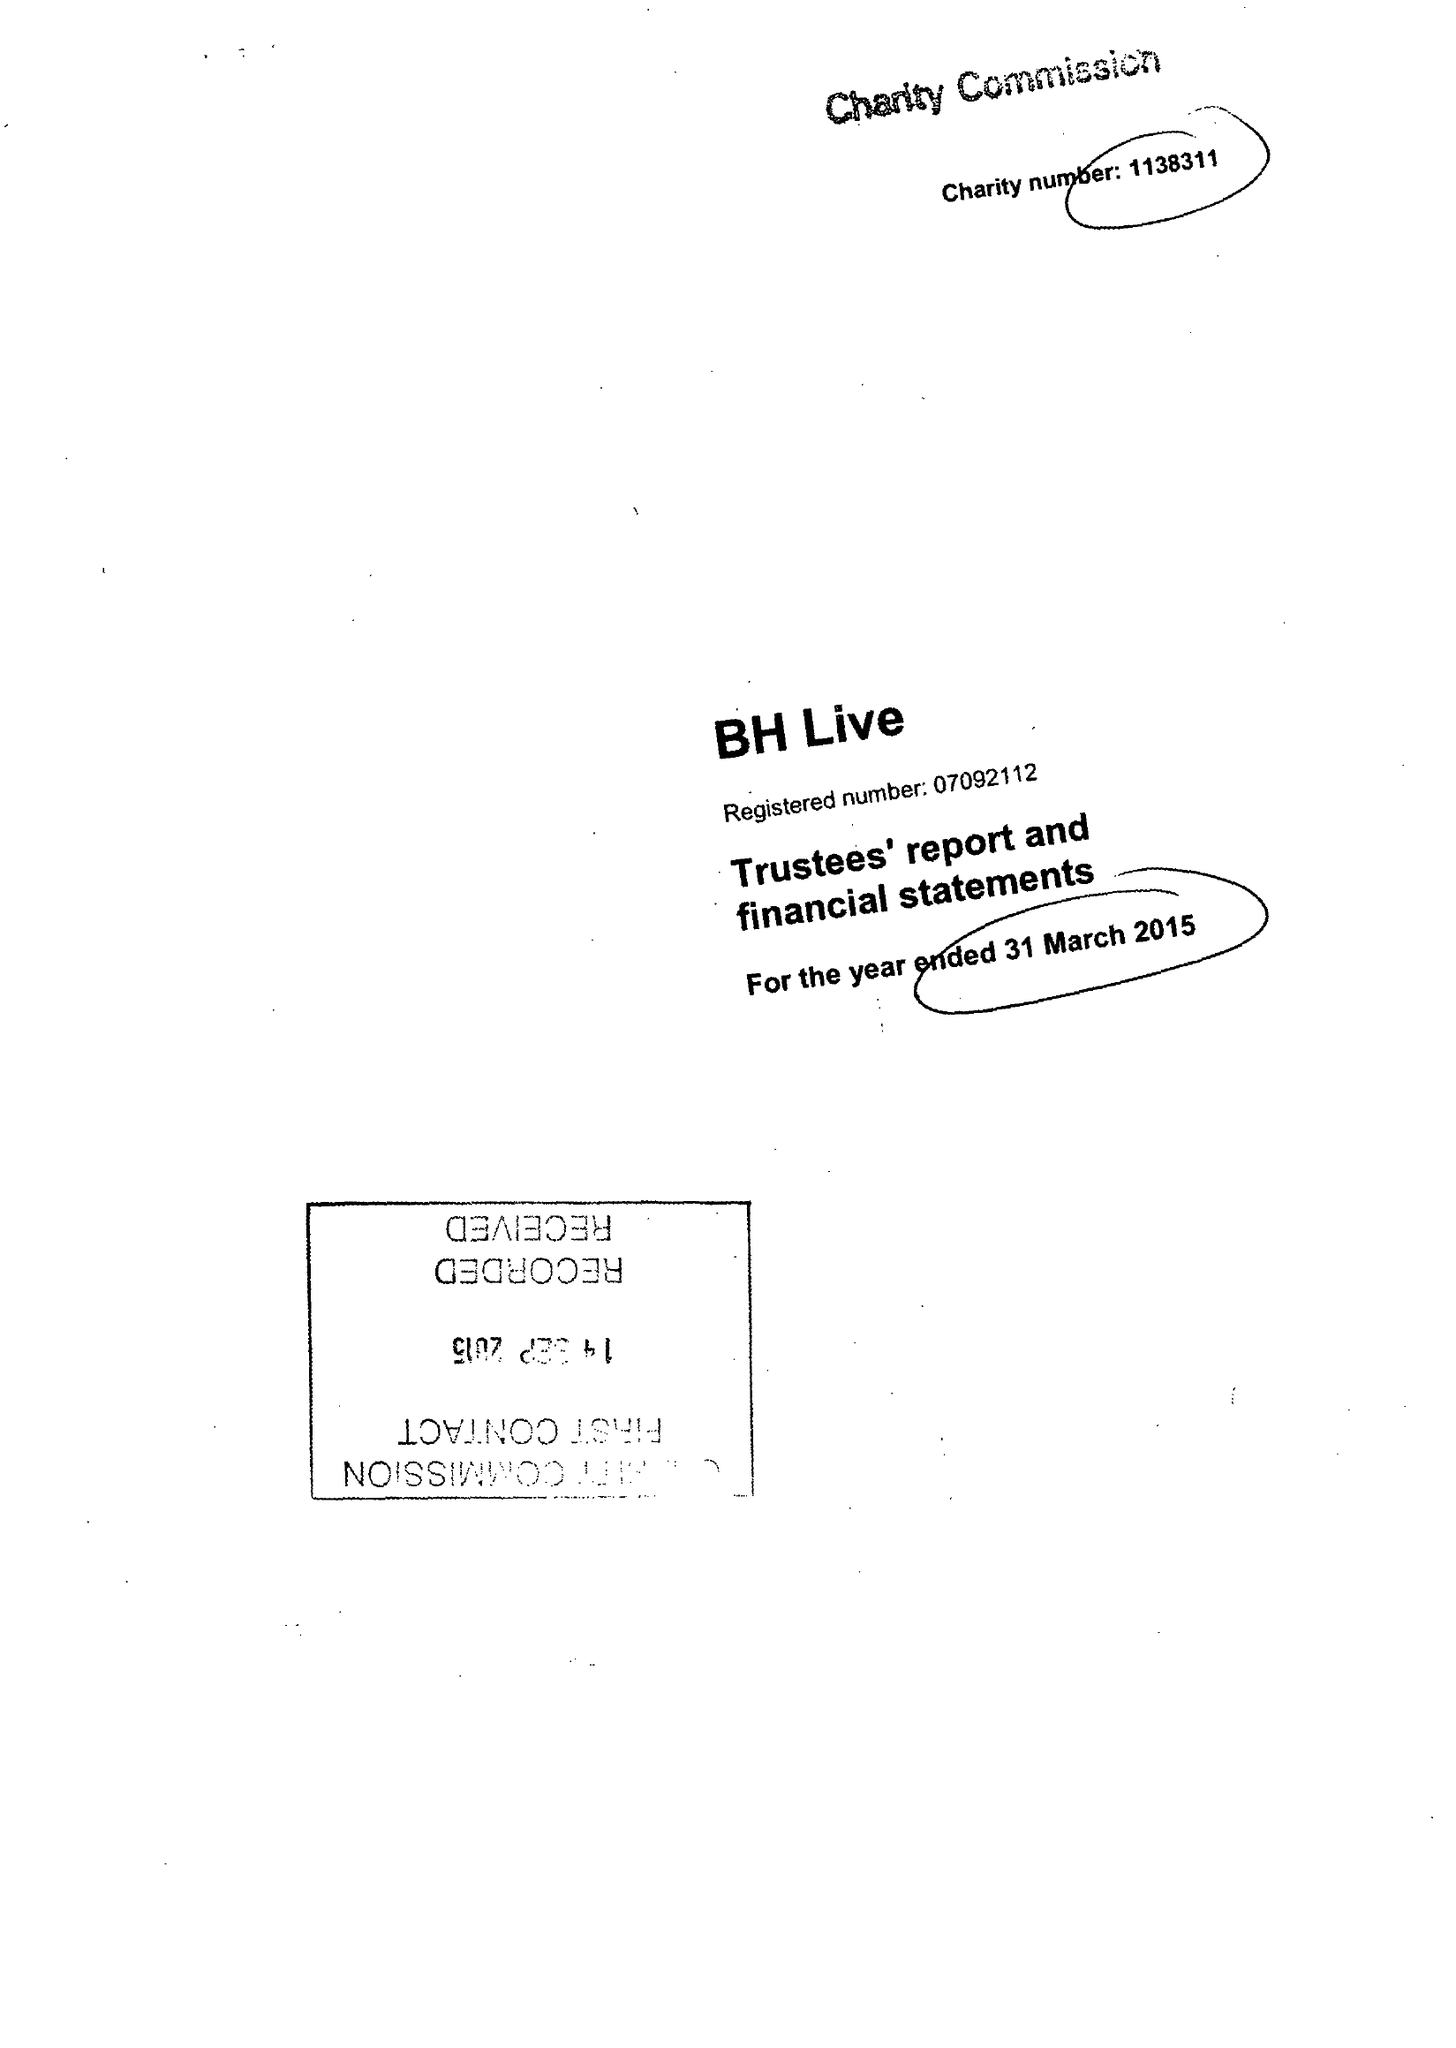What is the value for the charity_name?
Answer the question using a single word or phrase. Bh Live 